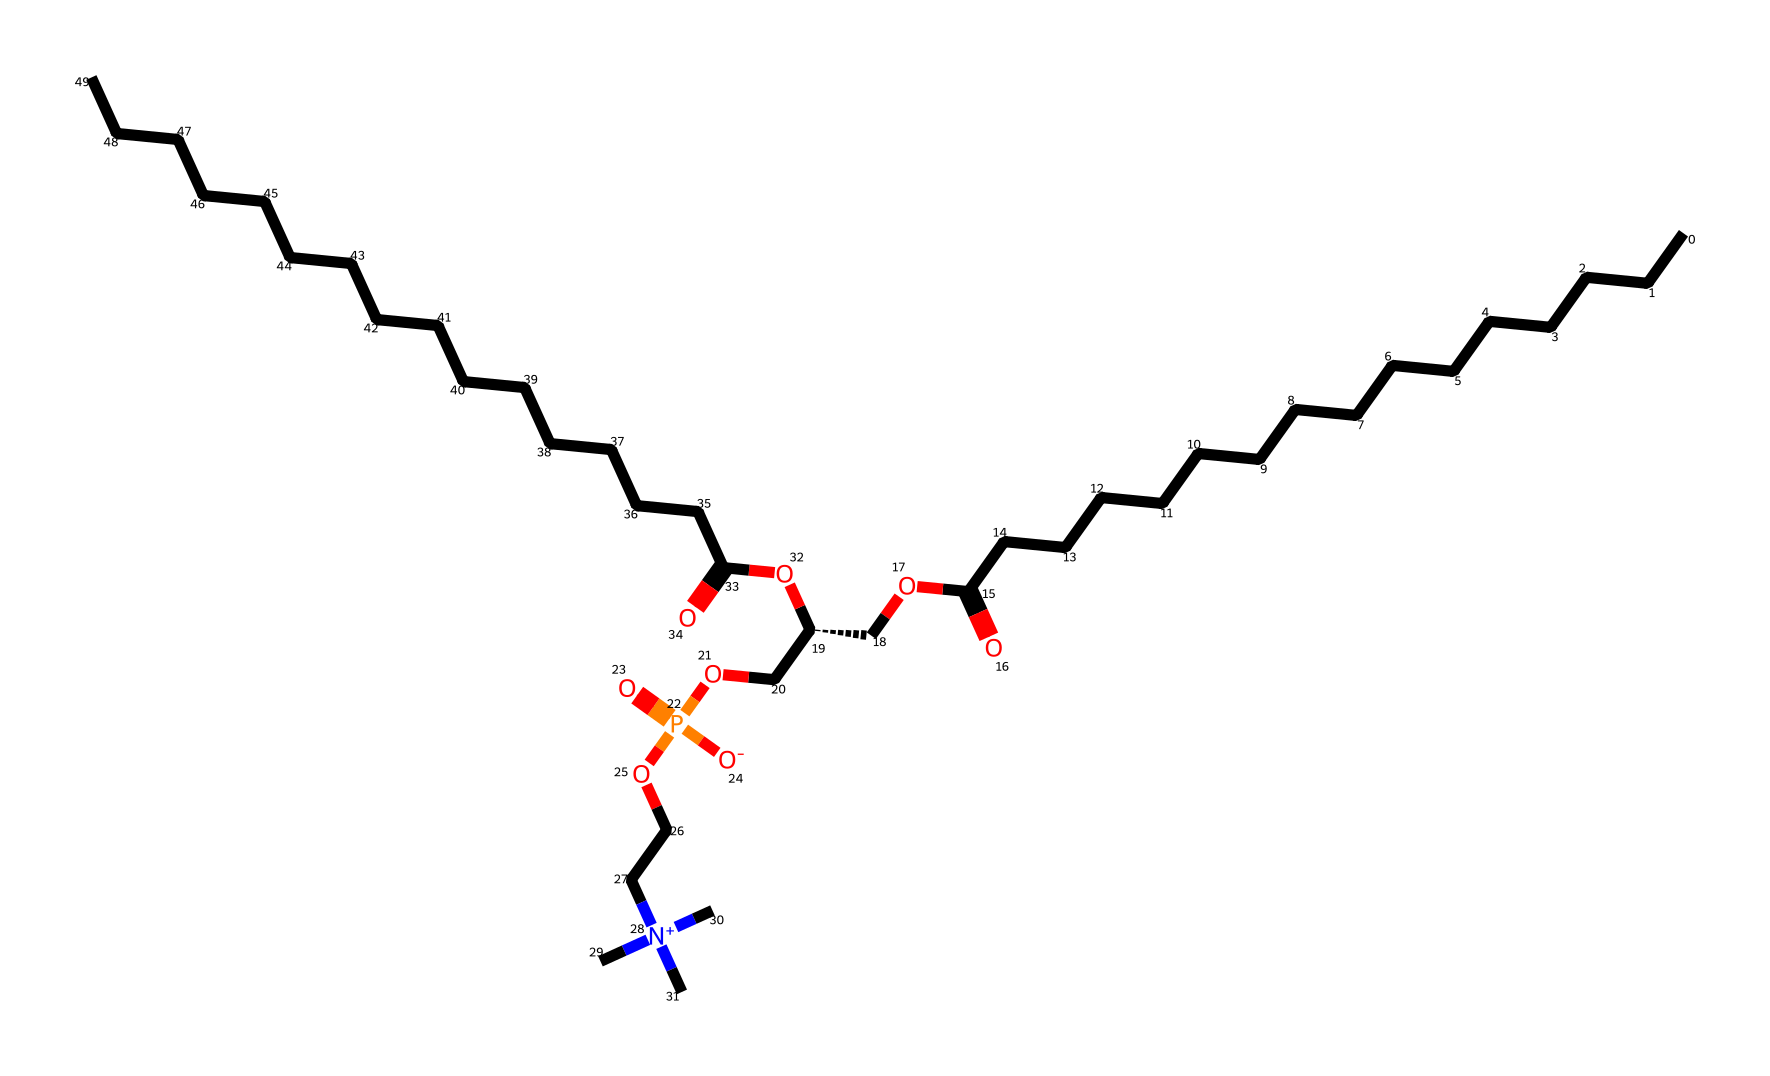What is the total number of carbon atoms in this molecule? By analyzing the SMILES representation, count the carbon atoms represented by "C" and "CC" groups. In phosphatidylcholine, there are 21 carbon atoms in total, considering both the fatty acid tails and the glycerol backbone.
Answer: 21 How many nitrogen atoms are present in the molecular structure? In the provided SMILES representation, we see one instance of "[N+]" which indicates a positively charged nitrogen atom. There are no other nitrogen elements indicated, so the total is one.
Answer: 1 What type of lipid is phosphatidylcholine classified as? Phosphatidylcholine is classified as a phospholipid due to the presence of phosphate groups and fatty acid tails. This classification is consistent with the structure observed in the SMILES, where the glycerol backbone is linked to fatty acid chains.
Answer: phospholipid What functional groups are indicated in the structure? The SMILES includes esters (represented by "OC(=O)"), a phosphate group ("P(=O)([O-])"), and a quaternary ammonium ("[N+](C)(C)C"), which indicate distinct functional groups typical of phospholipids. One can identify these functional groups by their respective elements and bonding configurations in the structure.
Answer: ester, phosphate, quaternary ammonium What is the role of phosphatidylcholine in vocal cord lubricants? Phosphatidylcholine functions as an emulsifier and lubricant, aiding in maintaining moisture and flexibility of the vocal cords due to its lipid nature, which forms a lipid bilayer mimicking cellular compositions.
Answer: emulsifier, lubricant 